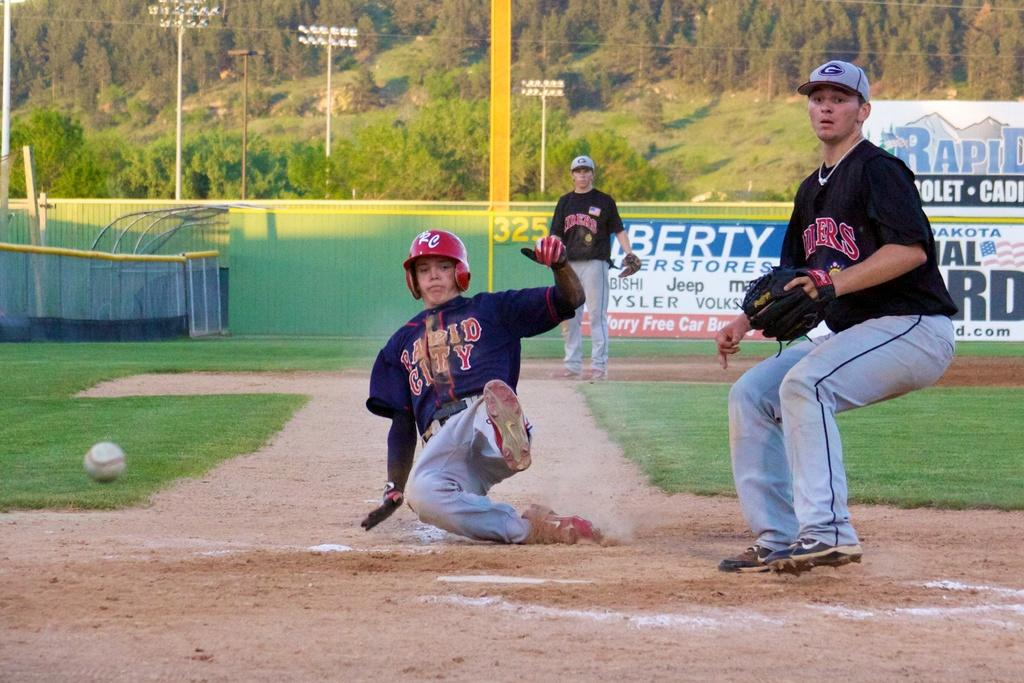<image>
Summarize the visual content of the image. A baseball player sliding home with a Rapid City jersey on 